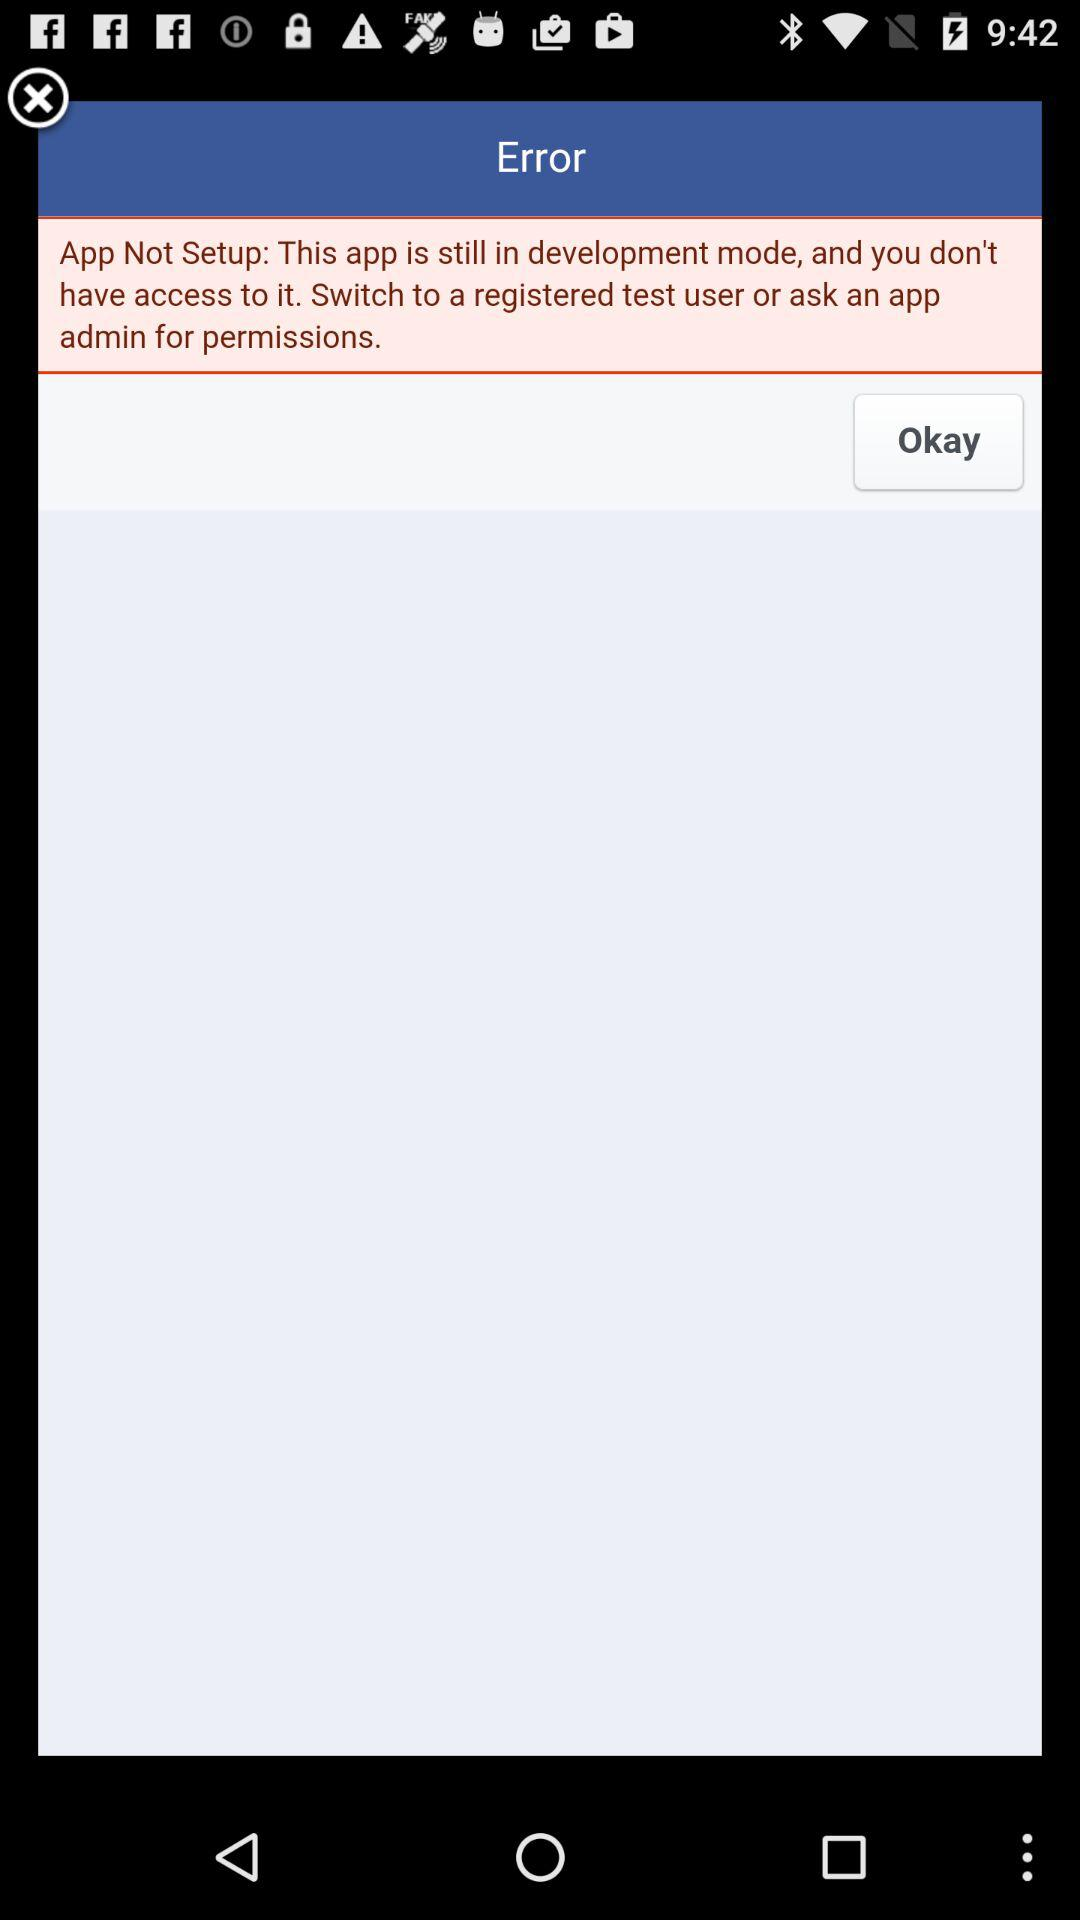Is "Okay" selected?
When the provided information is insufficient, respond with <no answer>. <no answer> 